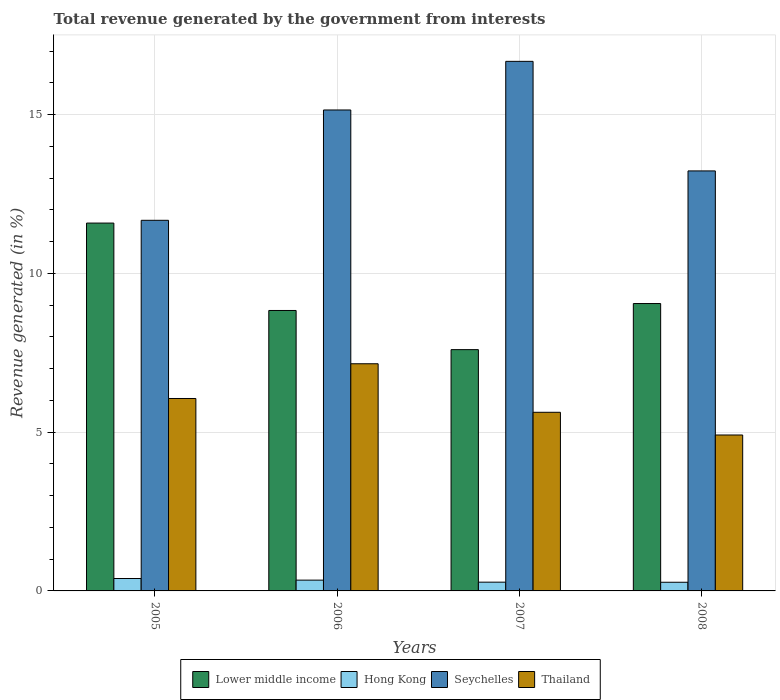How many different coloured bars are there?
Ensure brevity in your answer.  4. Are the number of bars on each tick of the X-axis equal?
Give a very brief answer. Yes. What is the label of the 1st group of bars from the left?
Ensure brevity in your answer.  2005. What is the total revenue generated in Thailand in 2006?
Offer a very short reply. 7.15. Across all years, what is the maximum total revenue generated in Lower middle income?
Your answer should be very brief. 11.58. Across all years, what is the minimum total revenue generated in Seychelles?
Provide a short and direct response. 11.67. In which year was the total revenue generated in Lower middle income maximum?
Provide a succinct answer. 2005. What is the total total revenue generated in Seychelles in the graph?
Offer a very short reply. 56.72. What is the difference between the total revenue generated in Thailand in 2005 and that in 2006?
Offer a very short reply. -1.09. What is the difference between the total revenue generated in Hong Kong in 2008 and the total revenue generated in Seychelles in 2007?
Offer a very short reply. -16.4. What is the average total revenue generated in Thailand per year?
Your response must be concise. 5.94. In the year 2005, what is the difference between the total revenue generated in Hong Kong and total revenue generated in Thailand?
Offer a very short reply. -5.67. In how many years, is the total revenue generated in Thailand greater than 11 %?
Ensure brevity in your answer.  0. What is the ratio of the total revenue generated in Lower middle income in 2007 to that in 2008?
Ensure brevity in your answer.  0.84. Is the total revenue generated in Lower middle income in 2005 less than that in 2008?
Your answer should be compact. No. Is the difference between the total revenue generated in Hong Kong in 2005 and 2006 greater than the difference between the total revenue generated in Thailand in 2005 and 2006?
Offer a very short reply. Yes. What is the difference between the highest and the second highest total revenue generated in Thailand?
Offer a very short reply. 1.09. What is the difference between the highest and the lowest total revenue generated in Thailand?
Ensure brevity in your answer.  2.24. What does the 3rd bar from the left in 2006 represents?
Offer a terse response. Seychelles. What does the 4th bar from the right in 2005 represents?
Keep it short and to the point. Lower middle income. How many years are there in the graph?
Give a very brief answer. 4. What is the difference between two consecutive major ticks on the Y-axis?
Give a very brief answer. 5. Does the graph contain grids?
Your answer should be compact. Yes. What is the title of the graph?
Give a very brief answer. Total revenue generated by the government from interests. Does "Vietnam" appear as one of the legend labels in the graph?
Offer a terse response. No. What is the label or title of the Y-axis?
Offer a very short reply. Revenue generated (in %). What is the Revenue generated (in %) in Lower middle income in 2005?
Provide a short and direct response. 11.58. What is the Revenue generated (in %) in Hong Kong in 2005?
Offer a terse response. 0.39. What is the Revenue generated (in %) in Seychelles in 2005?
Offer a very short reply. 11.67. What is the Revenue generated (in %) of Thailand in 2005?
Keep it short and to the point. 6.06. What is the Revenue generated (in %) in Lower middle income in 2006?
Provide a succinct answer. 8.83. What is the Revenue generated (in %) in Hong Kong in 2006?
Provide a succinct answer. 0.34. What is the Revenue generated (in %) of Seychelles in 2006?
Ensure brevity in your answer.  15.15. What is the Revenue generated (in %) in Thailand in 2006?
Keep it short and to the point. 7.15. What is the Revenue generated (in %) in Lower middle income in 2007?
Your response must be concise. 7.6. What is the Revenue generated (in %) of Hong Kong in 2007?
Your response must be concise. 0.28. What is the Revenue generated (in %) in Seychelles in 2007?
Keep it short and to the point. 16.68. What is the Revenue generated (in %) in Thailand in 2007?
Your answer should be compact. 5.63. What is the Revenue generated (in %) in Lower middle income in 2008?
Ensure brevity in your answer.  9.05. What is the Revenue generated (in %) in Hong Kong in 2008?
Your answer should be very brief. 0.27. What is the Revenue generated (in %) in Seychelles in 2008?
Provide a short and direct response. 13.23. What is the Revenue generated (in %) in Thailand in 2008?
Give a very brief answer. 4.91. Across all years, what is the maximum Revenue generated (in %) in Lower middle income?
Provide a short and direct response. 11.58. Across all years, what is the maximum Revenue generated (in %) in Hong Kong?
Keep it short and to the point. 0.39. Across all years, what is the maximum Revenue generated (in %) in Seychelles?
Your answer should be compact. 16.68. Across all years, what is the maximum Revenue generated (in %) of Thailand?
Offer a terse response. 7.15. Across all years, what is the minimum Revenue generated (in %) in Lower middle income?
Give a very brief answer. 7.6. Across all years, what is the minimum Revenue generated (in %) in Hong Kong?
Ensure brevity in your answer.  0.27. Across all years, what is the minimum Revenue generated (in %) of Seychelles?
Ensure brevity in your answer.  11.67. Across all years, what is the minimum Revenue generated (in %) of Thailand?
Offer a very short reply. 4.91. What is the total Revenue generated (in %) of Lower middle income in the graph?
Provide a short and direct response. 37.06. What is the total Revenue generated (in %) in Hong Kong in the graph?
Ensure brevity in your answer.  1.28. What is the total Revenue generated (in %) of Seychelles in the graph?
Your answer should be very brief. 56.72. What is the total Revenue generated (in %) of Thailand in the graph?
Your response must be concise. 23.75. What is the difference between the Revenue generated (in %) in Lower middle income in 2005 and that in 2006?
Your response must be concise. 2.75. What is the difference between the Revenue generated (in %) in Hong Kong in 2005 and that in 2006?
Your response must be concise. 0.05. What is the difference between the Revenue generated (in %) of Seychelles in 2005 and that in 2006?
Your answer should be very brief. -3.47. What is the difference between the Revenue generated (in %) in Thailand in 2005 and that in 2006?
Give a very brief answer. -1.09. What is the difference between the Revenue generated (in %) in Lower middle income in 2005 and that in 2007?
Keep it short and to the point. 3.99. What is the difference between the Revenue generated (in %) in Hong Kong in 2005 and that in 2007?
Give a very brief answer. 0.12. What is the difference between the Revenue generated (in %) in Seychelles in 2005 and that in 2007?
Provide a succinct answer. -5.01. What is the difference between the Revenue generated (in %) of Thailand in 2005 and that in 2007?
Offer a very short reply. 0.43. What is the difference between the Revenue generated (in %) in Lower middle income in 2005 and that in 2008?
Ensure brevity in your answer.  2.53. What is the difference between the Revenue generated (in %) in Hong Kong in 2005 and that in 2008?
Offer a very short reply. 0.12. What is the difference between the Revenue generated (in %) in Seychelles in 2005 and that in 2008?
Your answer should be very brief. -1.56. What is the difference between the Revenue generated (in %) of Thailand in 2005 and that in 2008?
Offer a very short reply. 1.15. What is the difference between the Revenue generated (in %) in Lower middle income in 2006 and that in 2007?
Ensure brevity in your answer.  1.23. What is the difference between the Revenue generated (in %) in Hong Kong in 2006 and that in 2007?
Offer a terse response. 0.06. What is the difference between the Revenue generated (in %) of Seychelles in 2006 and that in 2007?
Keep it short and to the point. -1.53. What is the difference between the Revenue generated (in %) in Thailand in 2006 and that in 2007?
Ensure brevity in your answer.  1.53. What is the difference between the Revenue generated (in %) in Lower middle income in 2006 and that in 2008?
Ensure brevity in your answer.  -0.22. What is the difference between the Revenue generated (in %) in Hong Kong in 2006 and that in 2008?
Offer a terse response. 0.07. What is the difference between the Revenue generated (in %) in Seychelles in 2006 and that in 2008?
Your answer should be compact. 1.92. What is the difference between the Revenue generated (in %) of Thailand in 2006 and that in 2008?
Provide a succinct answer. 2.24. What is the difference between the Revenue generated (in %) of Lower middle income in 2007 and that in 2008?
Make the answer very short. -1.45. What is the difference between the Revenue generated (in %) in Hong Kong in 2007 and that in 2008?
Provide a short and direct response. 0. What is the difference between the Revenue generated (in %) in Seychelles in 2007 and that in 2008?
Keep it short and to the point. 3.45. What is the difference between the Revenue generated (in %) of Thailand in 2007 and that in 2008?
Give a very brief answer. 0.72. What is the difference between the Revenue generated (in %) in Lower middle income in 2005 and the Revenue generated (in %) in Hong Kong in 2006?
Offer a very short reply. 11.24. What is the difference between the Revenue generated (in %) of Lower middle income in 2005 and the Revenue generated (in %) of Seychelles in 2006?
Provide a succinct answer. -3.56. What is the difference between the Revenue generated (in %) in Lower middle income in 2005 and the Revenue generated (in %) in Thailand in 2006?
Offer a very short reply. 4.43. What is the difference between the Revenue generated (in %) in Hong Kong in 2005 and the Revenue generated (in %) in Seychelles in 2006?
Offer a very short reply. -14.75. What is the difference between the Revenue generated (in %) of Hong Kong in 2005 and the Revenue generated (in %) of Thailand in 2006?
Your response must be concise. -6.76. What is the difference between the Revenue generated (in %) in Seychelles in 2005 and the Revenue generated (in %) in Thailand in 2006?
Offer a terse response. 4.52. What is the difference between the Revenue generated (in %) of Lower middle income in 2005 and the Revenue generated (in %) of Hong Kong in 2007?
Your response must be concise. 11.31. What is the difference between the Revenue generated (in %) of Lower middle income in 2005 and the Revenue generated (in %) of Seychelles in 2007?
Offer a terse response. -5.09. What is the difference between the Revenue generated (in %) of Lower middle income in 2005 and the Revenue generated (in %) of Thailand in 2007?
Your response must be concise. 5.96. What is the difference between the Revenue generated (in %) of Hong Kong in 2005 and the Revenue generated (in %) of Seychelles in 2007?
Your answer should be very brief. -16.29. What is the difference between the Revenue generated (in %) of Hong Kong in 2005 and the Revenue generated (in %) of Thailand in 2007?
Provide a short and direct response. -5.23. What is the difference between the Revenue generated (in %) of Seychelles in 2005 and the Revenue generated (in %) of Thailand in 2007?
Keep it short and to the point. 6.05. What is the difference between the Revenue generated (in %) of Lower middle income in 2005 and the Revenue generated (in %) of Hong Kong in 2008?
Make the answer very short. 11.31. What is the difference between the Revenue generated (in %) in Lower middle income in 2005 and the Revenue generated (in %) in Seychelles in 2008?
Give a very brief answer. -1.64. What is the difference between the Revenue generated (in %) in Lower middle income in 2005 and the Revenue generated (in %) in Thailand in 2008?
Make the answer very short. 6.67. What is the difference between the Revenue generated (in %) in Hong Kong in 2005 and the Revenue generated (in %) in Seychelles in 2008?
Ensure brevity in your answer.  -12.84. What is the difference between the Revenue generated (in %) in Hong Kong in 2005 and the Revenue generated (in %) in Thailand in 2008?
Offer a terse response. -4.52. What is the difference between the Revenue generated (in %) of Seychelles in 2005 and the Revenue generated (in %) of Thailand in 2008?
Your answer should be very brief. 6.76. What is the difference between the Revenue generated (in %) in Lower middle income in 2006 and the Revenue generated (in %) in Hong Kong in 2007?
Provide a succinct answer. 8.56. What is the difference between the Revenue generated (in %) of Lower middle income in 2006 and the Revenue generated (in %) of Seychelles in 2007?
Your answer should be compact. -7.85. What is the difference between the Revenue generated (in %) of Lower middle income in 2006 and the Revenue generated (in %) of Thailand in 2007?
Make the answer very short. 3.21. What is the difference between the Revenue generated (in %) in Hong Kong in 2006 and the Revenue generated (in %) in Seychelles in 2007?
Your answer should be compact. -16.34. What is the difference between the Revenue generated (in %) of Hong Kong in 2006 and the Revenue generated (in %) of Thailand in 2007?
Your response must be concise. -5.29. What is the difference between the Revenue generated (in %) in Seychelles in 2006 and the Revenue generated (in %) in Thailand in 2007?
Ensure brevity in your answer.  9.52. What is the difference between the Revenue generated (in %) of Lower middle income in 2006 and the Revenue generated (in %) of Hong Kong in 2008?
Offer a very short reply. 8.56. What is the difference between the Revenue generated (in %) in Lower middle income in 2006 and the Revenue generated (in %) in Seychelles in 2008?
Your answer should be very brief. -4.4. What is the difference between the Revenue generated (in %) of Lower middle income in 2006 and the Revenue generated (in %) of Thailand in 2008?
Your answer should be very brief. 3.92. What is the difference between the Revenue generated (in %) of Hong Kong in 2006 and the Revenue generated (in %) of Seychelles in 2008?
Offer a terse response. -12.89. What is the difference between the Revenue generated (in %) in Hong Kong in 2006 and the Revenue generated (in %) in Thailand in 2008?
Your answer should be compact. -4.57. What is the difference between the Revenue generated (in %) in Seychelles in 2006 and the Revenue generated (in %) in Thailand in 2008?
Your answer should be compact. 10.24. What is the difference between the Revenue generated (in %) in Lower middle income in 2007 and the Revenue generated (in %) in Hong Kong in 2008?
Offer a terse response. 7.33. What is the difference between the Revenue generated (in %) in Lower middle income in 2007 and the Revenue generated (in %) in Seychelles in 2008?
Make the answer very short. -5.63. What is the difference between the Revenue generated (in %) of Lower middle income in 2007 and the Revenue generated (in %) of Thailand in 2008?
Keep it short and to the point. 2.69. What is the difference between the Revenue generated (in %) in Hong Kong in 2007 and the Revenue generated (in %) in Seychelles in 2008?
Make the answer very short. -12.95. What is the difference between the Revenue generated (in %) of Hong Kong in 2007 and the Revenue generated (in %) of Thailand in 2008?
Offer a terse response. -4.63. What is the difference between the Revenue generated (in %) in Seychelles in 2007 and the Revenue generated (in %) in Thailand in 2008?
Give a very brief answer. 11.77. What is the average Revenue generated (in %) in Lower middle income per year?
Provide a short and direct response. 9.27. What is the average Revenue generated (in %) in Hong Kong per year?
Give a very brief answer. 0.32. What is the average Revenue generated (in %) in Seychelles per year?
Your response must be concise. 14.18. What is the average Revenue generated (in %) in Thailand per year?
Your answer should be very brief. 5.94. In the year 2005, what is the difference between the Revenue generated (in %) of Lower middle income and Revenue generated (in %) of Hong Kong?
Your answer should be very brief. 11.19. In the year 2005, what is the difference between the Revenue generated (in %) of Lower middle income and Revenue generated (in %) of Seychelles?
Your answer should be compact. -0.09. In the year 2005, what is the difference between the Revenue generated (in %) in Lower middle income and Revenue generated (in %) in Thailand?
Keep it short and to the point. 5.52. In the year 2005, what is the difference between the Revenue generated (in %) in Hong Kong and Revenue generated (in %) in Seychelles?
Offer a very short reply. -11.28. In the year 2005, what is the difference between the Revenue generated (in %) in Hong Kong and Revenue generated (in %) in Thailand?
Your answer should be very brief. -5.67. In the year 2005, what is the difference between the Revenue generated (in %) in Seychelles and Revenue generated (in %) in Thailand?
Your response must be concise. 5.61. In the year 2006, what is the difference between the Revenue generated (in %) of Lower middle income and Revenue generated (in %) of Hong Kong?
Your answer should be compact. 8.49. In the year 2006, what is the difference between the Revenue generated (in %) in Lower middle income and Revenue generated (in %) in Seychelles?
Keep it short and to the point. -6.31. In the year 2006, what is the difference between the Revenue generated (in %) of Lower middle income and Revenue generated (in %) of Thailand?
Make the answer very short. 1.68. In the year 2006, what is the difference between the Revenue generated (in %) in Hong Kong and Revenue generated (in %) in Seychelles?
Offer a terse response. -14.81. In the year 2006, what is the difference between the Revenue generated (in %) of Hong Kong and Revenue generated (in %) of Thailand?
Give a very brief answer. -6.81. In the year 2006, what is the difference between the Revenue generated (in %) of Seychelles and Revenue generated (in %) of Thailand?
Offer a terse response. 7.99. In the year 2007, what is the difference between the Revenue generated (in %) of Lower middle income and Revenue generated (in %) of Hong Kong?
Offer a terse response. 7.32. In the year 2007, what is the difference between the Revenue generated (in %) in Lower middle income and Revenue generated (in %) in Seychelles?
Your response must be concise. -9.08. In the year 2007, what is the difference between the Revenue generated (in %) in Lower middle income and Revenue generated (in %) in Thailand?
Offer a very short reply. 1.97. In the year 2007, what is the difference between the Revenue generated (in %) of Hong Kong and Revenue generated (in %) of Seychelles?
Provide a short and direct response. -16.4. In the year 2007, what is the difference between the Revenue generated (in %) of Hong Kong and Revenue generated (in %) of Thailand?
Your answer should be very brief. -5.35. In the year 2007, what is the difference between the Revenue generated (in %) of Seychelles and Revenue generated (in %) of Thailand?
Keep it short and to the point. 11.05. In the year 2008, what is the difference between the Revenue generated (in %) in Lower middle income and Revenue generated (in %) in Hong Kong?
Your answer should be very brief. 8.78. In the year 2008, what is the difference between the Revenue generated (in %) in Lower middle income and Revenue generated (in %) in Seychelles?
Offer a very short reply. -4.18. In the year 2008, what is the difference between the Revenue generated (in %) in Lower middle income and Revenue generated (in %) in Thailand?
Your answer should be compact. 4.14. In the year 2008, what is the difference between the Revenue generated (in %) in Hong Kong and Revenue generated (in %) in Seychelles?
Keep it short and to the point. -12.95. In the year 2008, what is the difference between the Revenue generated (in %) of Hong Kong and Revenue generated (in %) of Thailand?
Give a very brief answer. -4.64. In the year 2008, what is the difference between the Revenue generated (in %) of Seychelles and Revenue generated (in %) of Thailand?
Your answer should be compact. 8.32. What is the ratio of the Revenue generated (in %) of Lower middle income in 2005 to that in 2006?
Give a very brief answer. 1.31. What is the ratio of the Revenue generated (in %) in Hong Kong in 2005 to that in 2006?
Offer a terse response. 1.15. What is the ratio of the Revenue generated (in %) in Seychelles in 2005 to that in 2006?
Your response must be concise. 0.77. What is the ratio of the Revenue generated (in %) of Thailand in 2005 to that in 2006?
Offer a very short reply. 0.85. What is the ratio of the Revenue generated (in %) in Lower middle income in 2005 to that in 2007?
Make the answer very short. 1.52. What is the ratio of the Revenue generated (in %) of Hong Kong in 2005 to that in 2007?
Offer a very short reply. 1.42. What is the ratio of the Revenue generated (in %) of Seychelles in 2005 to that in 2007?
Keep it short and to the point. 0.7. What is the ratio of the Revenue generated (in %) of Thailand in 2005 to that in 2007?
Your response must be concise. 1.08. What is the ratio of the Revenue generated (in %) of Lower middle income in 2005 to that in 2008?
Your answer should be very brief. 1.28. What is the ratio of the Revenue generated (in %) in Hong Kong in 2005 to that in 2008?
Offer a very short reply. 1.43. What is the ratio of the Revenue generated (in %) in Seychelles in 2005 to that in 2008?
Keep it short and to the point. 0.88. What is the ratio of the Revenue generated (in %) of Thailand in 2005 to that in 2008?
Give a very brief answer. 1.23. What is the ratio of the Revenue generated (in %) in Lower middle income in 2006 to that in 2007?
Your answer should be very brief. 1.16. What is the ratio of the Revenue generated (in %) of Hong Kong in 2006 to that in 2007?
Offer a terse response. 1.23. What is the ratio of the Revenue generated (in %) in Seychelles in 2006 to that in 2007?
Make the answer very short. 0.91. What is the ratio of the Revenue generated (in %) in Thailand in 2006 to that in 2007?
Give a very brief answer. 1.27. What is the ratio of the Revenue generated (in %) of Lower middle income in 2006 to that in 2008?
Provide a short and direct response. 0.98. What is the ratio of the Revenue generated (in %) of Hong Kong in 2006 to that in 2008?
Make the answer very short. 1.25. What is the ratio of the Revenue generated (in %) in Seychelles in 2006 to that in 2008?
Offer a very short reply. 1.15. What is the ratio of the Revenue generated (in %) in Thailand in 2006 to that in 2008?
Give a very brief answer. 1.46. What is the ratio of the Revenue generated (in %) of Lower middle income in 2007 to that in 2008?
Offer a terse response. 0.84. What is the ratio of the Revenue generated (in %) of Hong Kong in 2007 to that in 2008?
Provide a succinct answer. 1.01. What is the ratio of the Revenue generated (in %) of Seychelles in 2007 to that in 2008?
Ensure brevity in your answer.  1.26. What is the ratio of the Revenue generated (in %) in Thailand in 2007 to that in 2008?
Provide a short and direct response. 1.15. What is the difference between the highest and the second highest Revenue generated (in %) of Lower middle income?
Your answer should be compact. 2.53. What is the difference between the highest and the second highest Revenue generated (in %) in Hong Kong?
Ensure brevity in your answer.  0.05. What is the difference between the highest and the second highest Revenue generated (in %) in Seychelles?
Provide a short and direct response. 1.53. What is the difference between the highest and the second highest Revenue generated (in %) in Thailand?
Offer a very short reply. 1.09. What is the difference between the highest and the lowest Revenue generated (in %) of Lower middle income?
Offer a terse response. 3.99. What is the difference between the highest and the lowest Revenue generated (in %) of Hong Kong?
Offer a terse response. 0.12. What is the difference between the highest and the lowest Revenue generated (in %) in Seychelles?
Your response must be concise. 5.01. What is the difference between the highest and the lowest Revenue generated (in %) of Thailand?
Your answer should be very brief. 2.24. 